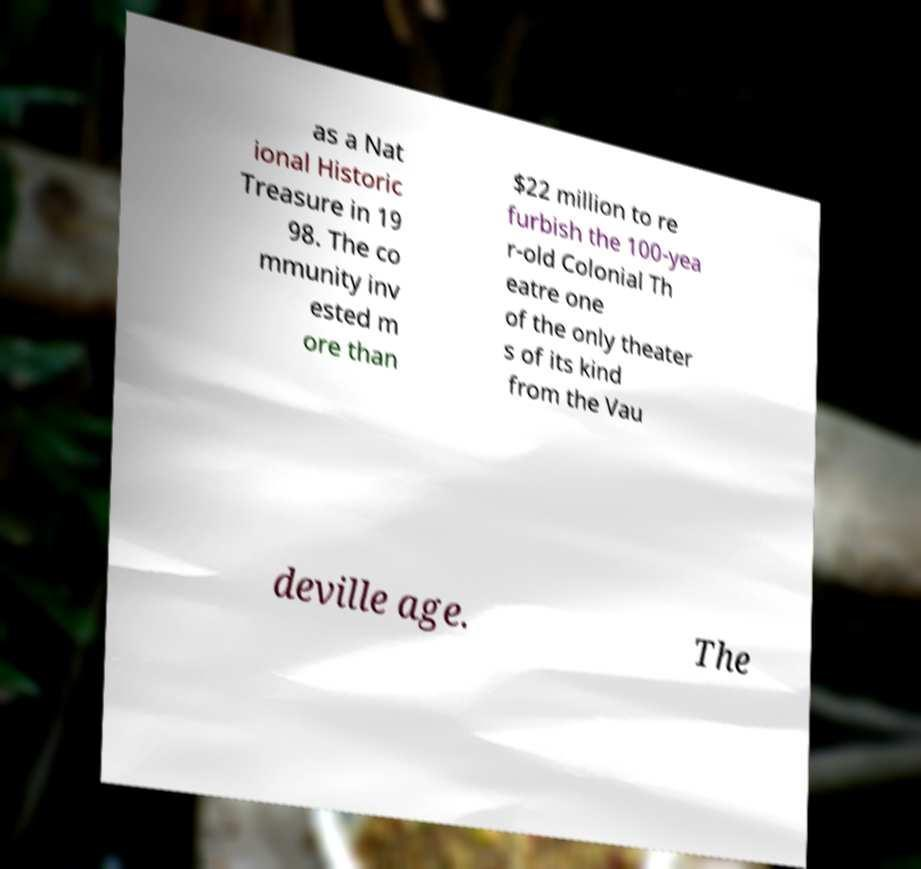Can you read and provide the text displayed in the image?This photo seems to have some interesting text. Can you extract and type it out for me? as a Nat ional Historic Treasure in 19 98. The co mmunity inv ested m ore than $22 million to re furbish the 100-yea r-old Colonial Th eatre one of the only theater s of its kind from the Vau deville age. The 